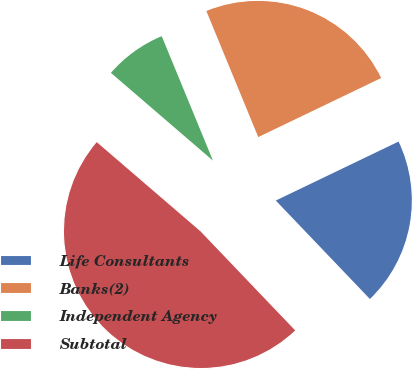<chart> <loc_0><loc_0><loc_500><loc_500><pie_chart><fcel>Life Consultants<fcel>Banks(2)<fcel>Independent Agency<fcel>Subtotal<nl><fcel>19.99%<fcel>24.09%<fcel>7.48%<fcel>48.45%<nl></chart> 